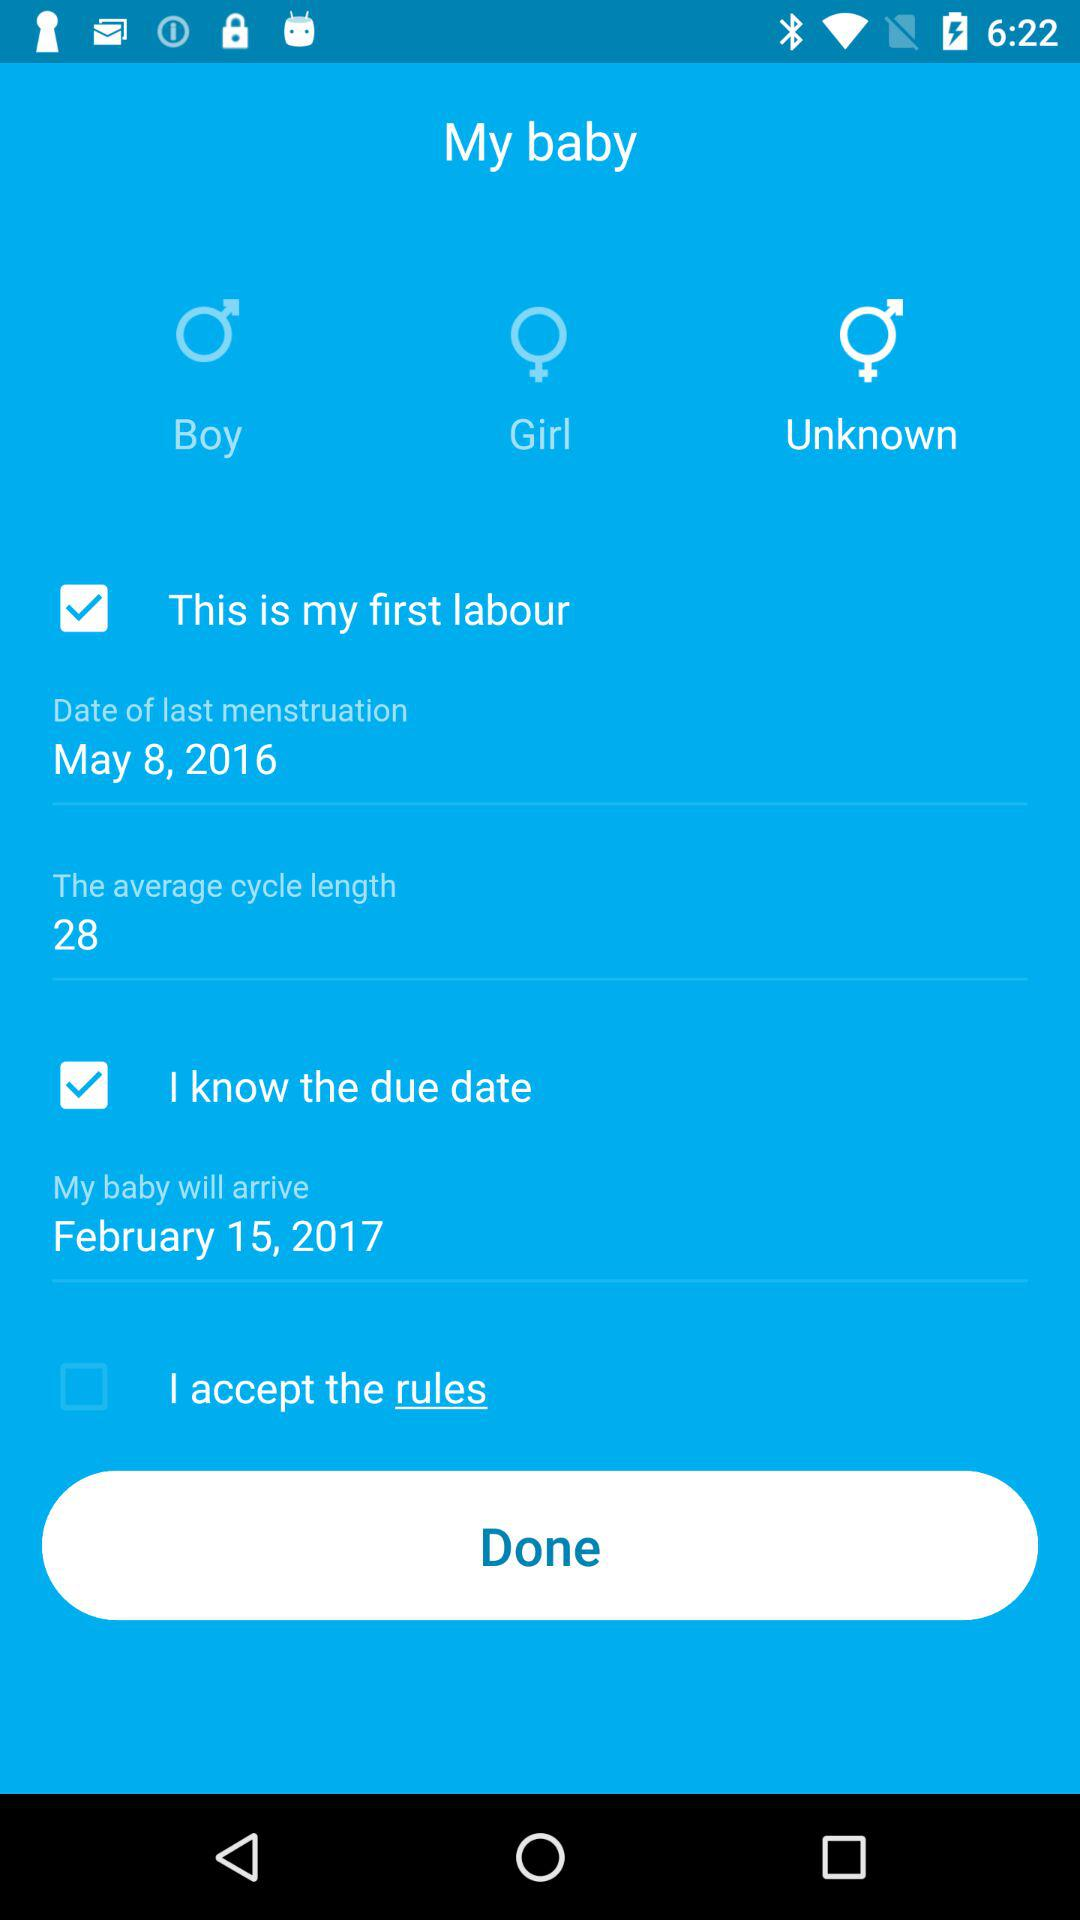What is the expected date of birth of the baby? The expected date of birth is February 15, 2017. 